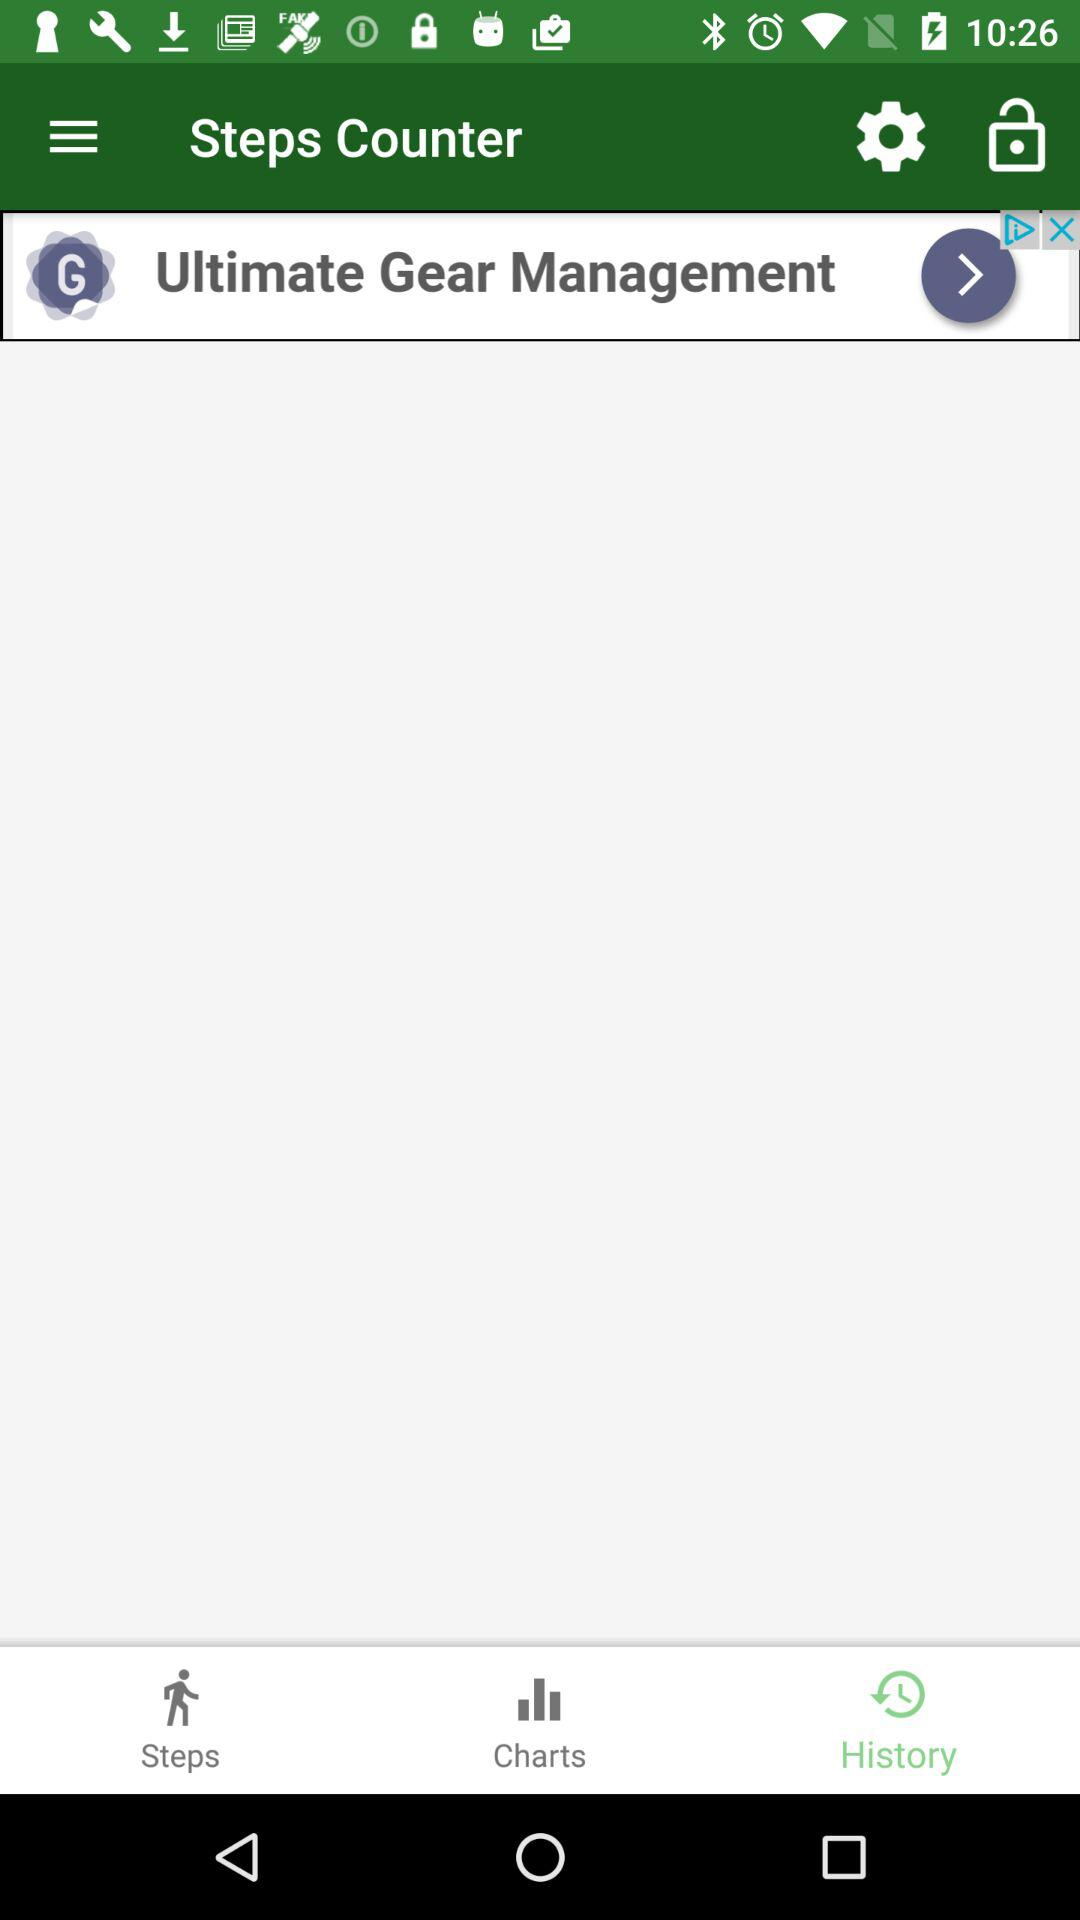Which tab are we currently in? You are currently in the "History" tab. 